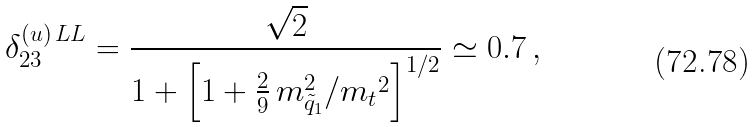<formula> <loc_0><loc_0><loc_500><loc_500>\delta _ { 2 3 } ^ { ( u ) \, L L } = \frac { \sqrt { 2 } } { 1 + \left [ 1 + \frac { 2 } { 9 } \, m _ { \tilde { q } _ { 1 } } ^ { 2 } / { m _ { t } } ^ { 2 } \right ] ^ { 1 / 2 } } \simeq 0 . 7 \, ,</formula> 